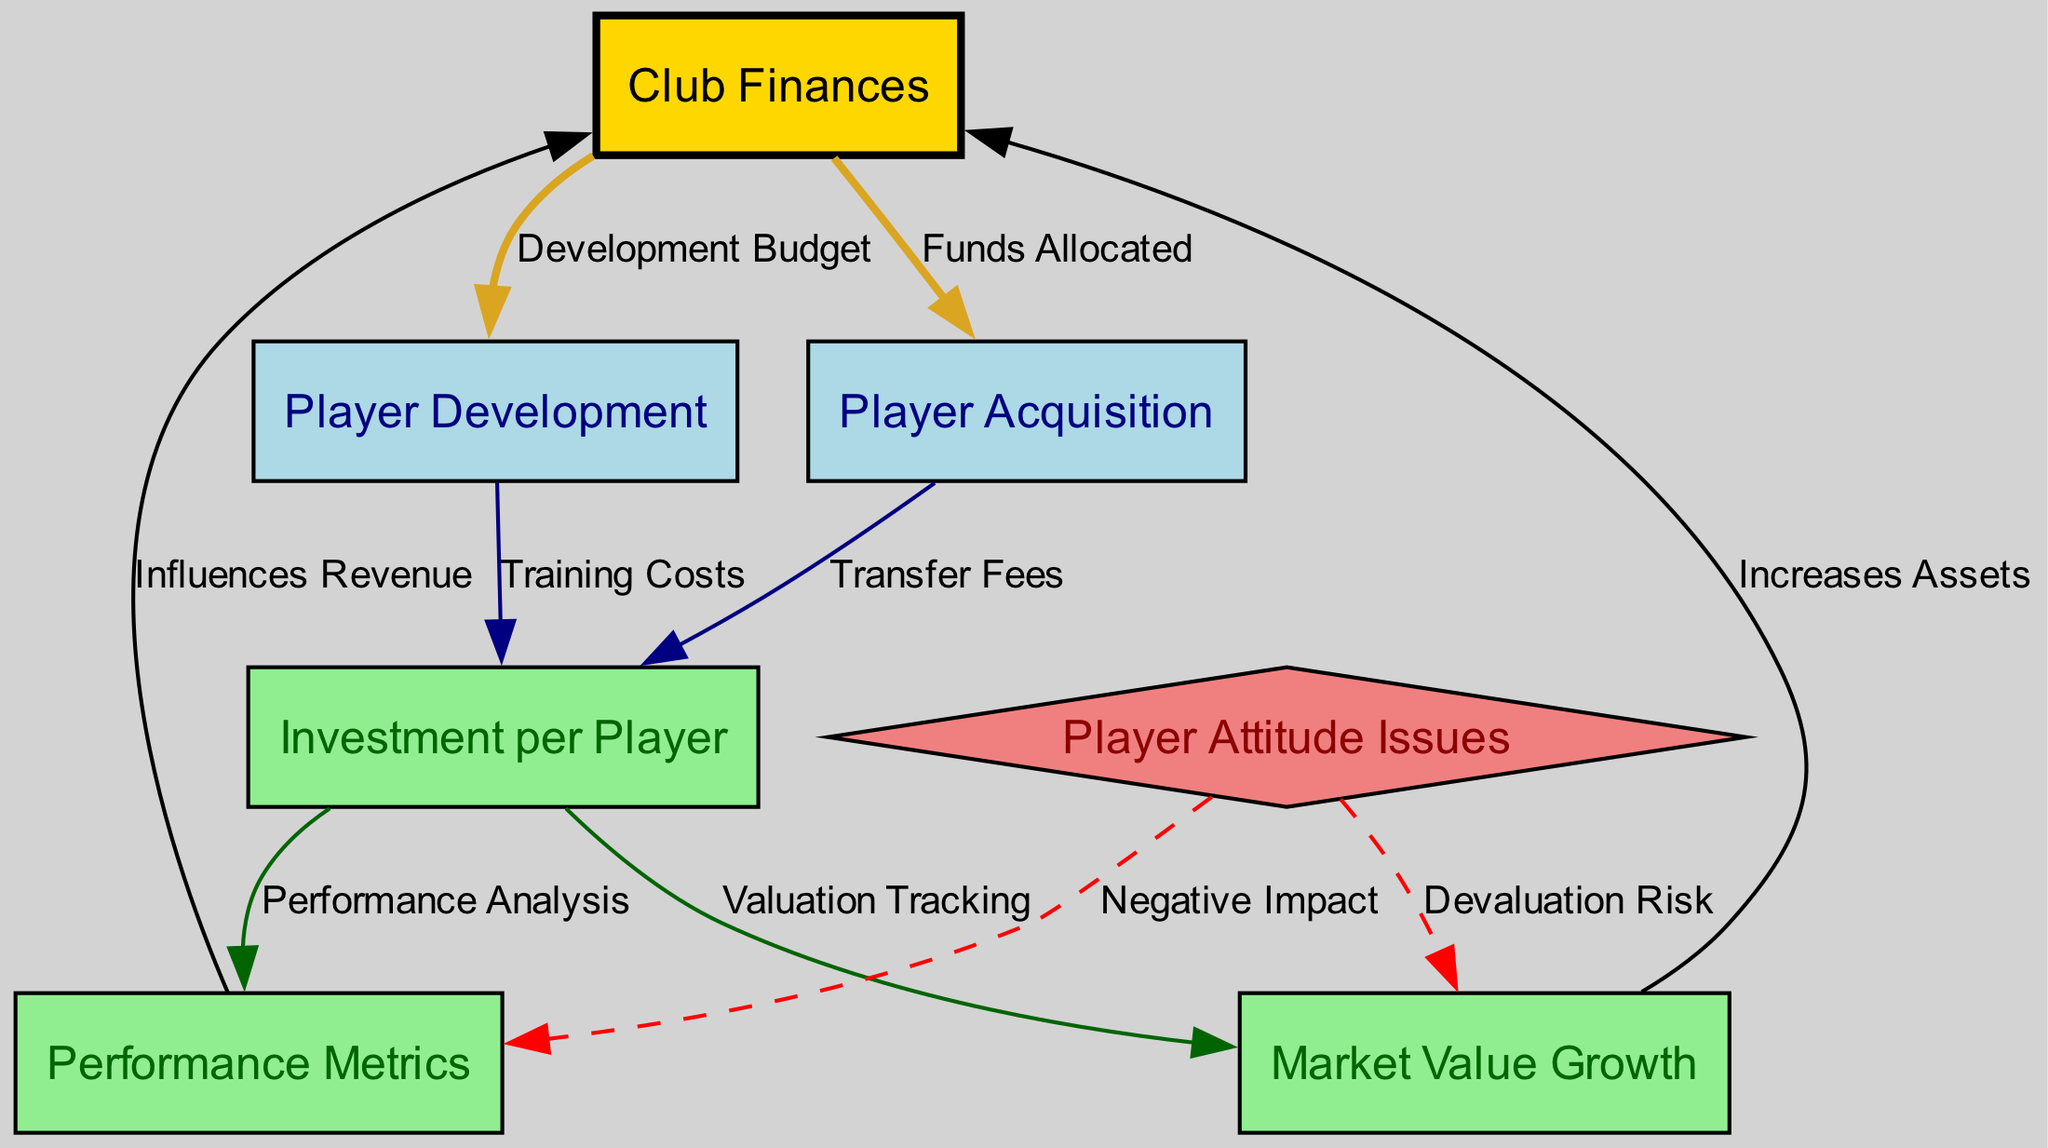What is the primary focus of this diagram? The diagram focuses on the relationship between club finances and player investment, detailing expenditures on player acquisition and development, and their returns in terms of performance and market value growth.
Answer: Club Finances and Player Investment How many nodes are there in the diagram? By counting each unique node listed in the data, we find there are a total of seven nodes identified in the diagram.
Answer: Seven What does "Funds Allocated" connect? The edge labeled "Funds Allocated" connects "Club Finances" to "Player Acquisition," indicating where the financial resources are directed.
Answer: Player Acquisition Which node is negatively impacted by "Player Attitude Issues"? "Performance Metrics" and "Market Value Growth" are both negatively impacted by "Player Attitude Issues," as indicated by the edges leading from the attitude issues node.
Answer: Performance Metrics, Market Value Growth What is the relationship between "Investment per Player" and "Performance Metrics"? The connection between "Investment per Player" and "Performance Metrics" suggests that the amount invested in each player correlates with the analysis of their performance.
Answer: Performance Analysis How does "Market Value Growth" influence "Club Finances"? "Market Value Growth" influences "Club Finances" by increasing the club's assets, indicating a direct financial benefit from the appreciation of players' market value.
Answer: Increases Assets What are the two focus areas for player investment listed in the diagram? The diagram lists "Player Acquisition" and "Player Development" as the two key focus areas for player investment, detailing how funds are utilized in these areas.
Answer: Player Acquisition, Player Development Which node is associated with "Valuation Tracking"? "Valuation Tracking" is associated with the "Market Value Growth" node, indicating an ongoing assessment of players' value after investment.
Answer: Market Value Growth What color represents "Club Finances" in the diagram? "Club Finances" is represented in gold color in the diagram to signify its importance compared to other nodes.
Answer: Gold 